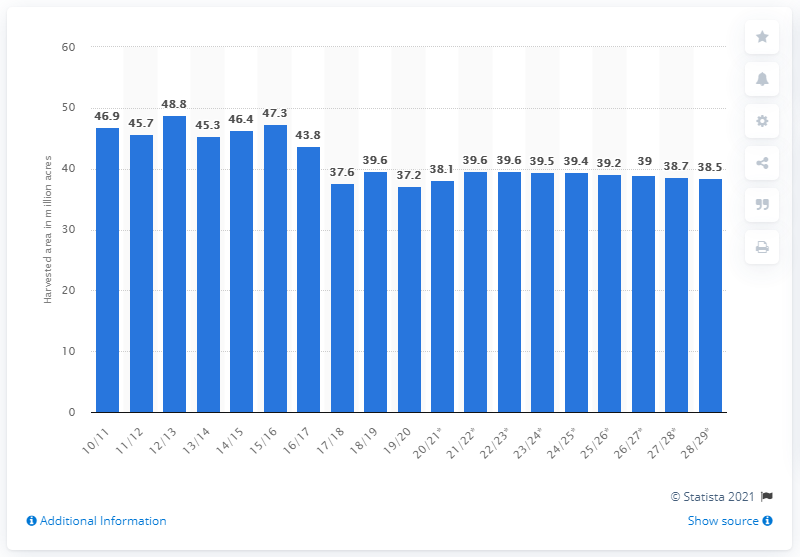Indicate a few pertinent items in this graphic. For the crop year of 2028/2029, it was projected that 38.5 hectares of wheat would be harvested. In the 2019/2020 crop year, the United States harvested a total wheat area of approximately 37.2 million acres. 